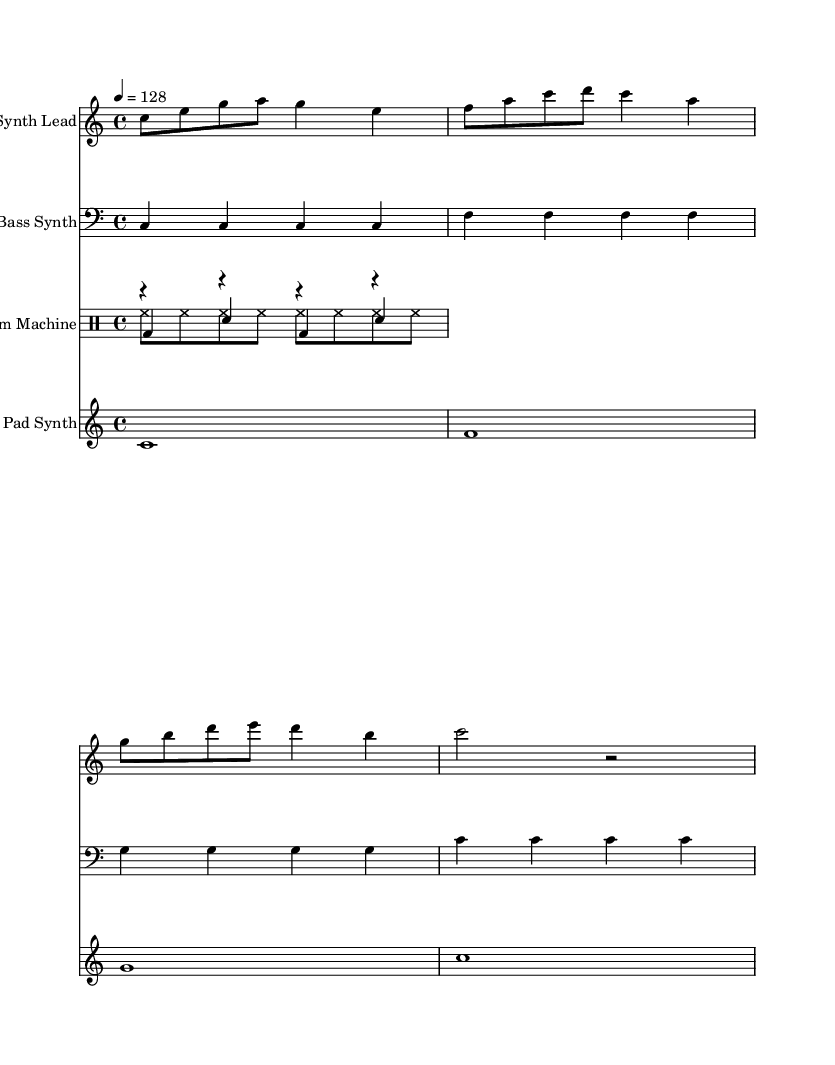What is the key signature of this music? The key signature is C major, which has no sharps or flats.
Answer: C major What is the time signature of this music? The time signature, indicated at the beginning of the score, is 4/4, meaning there are four beats per measure.
Answer: 4/4 What is the tempo marking in this music? The tempo marking is indicated as 4 = 128, which shows the beats per minute (BPM) for the piece.
Answer: 128 How many instruments are included in this sheet music? The score includes four distinct parts: Synth Lead, Bass Synth, Drum Machine, and Pad Synth. Counting these gives a total of four instruments.
Answer: 4 Which instrument has the highest pitch range? The Synth Lead plays in the treble clef and is positioned in a higher octave compared to the bass clef of the Bass Synth, making it the highest.
Answer: Synth Lead Why does the Bass Synth use a repeating pattern? The Bass Synth shows consistency and repetition in its pattern, often found in electronic dance music to create a steady foundation and maintain groove. This repetition helps to establish a rhythmic feel that is characteristic of the genre.
Answer: Repetition What rhythmic style is used in the Drum Machine section? The drum machine part uses electronic beats and a common pattern consisting of bass and snare hits, typical of electronic dance music, characterized by a standard kick-snare relationship and hi-hat sequences.
Answer: Electronic beats 